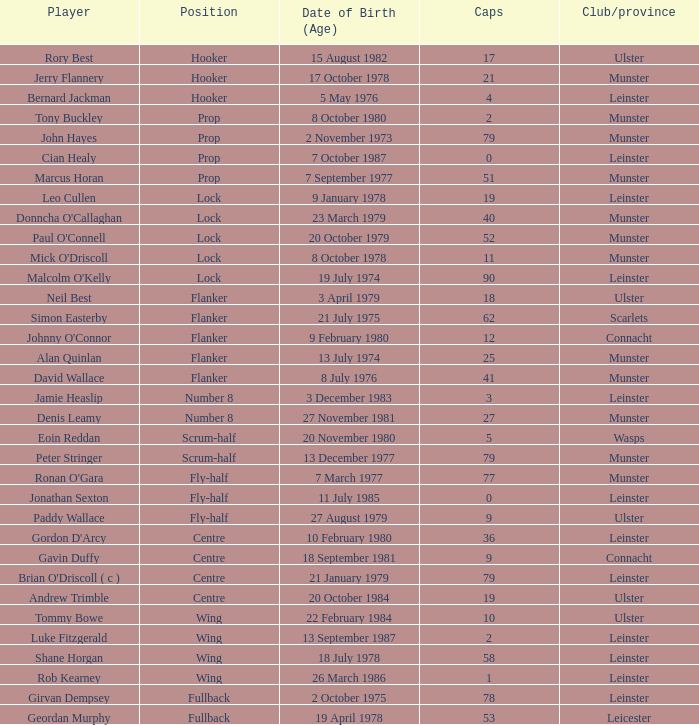Can you parse all the data within this table? {'header': ['Player', 'Position', 'Date of Birth (Age)', 'Caps', 'Club/province'], 'rows': [['Rory Best', 'Hooker', '15 August 1982', '17', 'Ulster'], ['Jerry Flannery', 'Hooker', '17 October 1978', '21', 'Munster'], ['Bernard Jackman', 'Hooker', '5 May 1976', '4', 'Leinster'], ['Tony Buckley', 'Prop', '8 October 1980', '2', 'Munster'], ['John Hayes', 'Prop', '2 November 1973', '79', 'Munster'], ['Cian Healy', 'Prop', '7 October 1987', '0', 'Leinster'], ['Marcus Horan', 'Prop', '7 September 1977', '51', 'Munster'], ['Leo Cullen', 'Lock', '9 January 1978', '19', 'Leinster'], ["Donncha O'Callaghan", 'Lock', '23 March 1979', '40', 'Munster'], ["Paul O'Connell", 'Lock', '20 October 1979', '52', 'Munster'], ["Mick O'Driscoll", 'Lock', '8 October 1978', '11', 'Munster'], ["Malcolm O'Kelly", 'Lock', '19 July 1974', '90', 'Leinster'], ['Neil Best', 'Flanker', '3 April 1979', '18', 'Ulster'], ['Simon Easterby', 'Flanker', '21 July 1975', '62', 'Scarlets'], ["Johnny O'Connor", 'Flanker', '9 February 1980', '12', 'Connacht'], ['Alan Quinlan', 'Flanker', '13 July 1974', '25', 'Munster'], ['David Wallace', 'Flanker', '8 July 1976', '41', 'Munster'], ['Jamie Heaslip', 'Number 8', '3 December 1983', '3', 'Leinster'], ['Denis Leamy', 'Number 8', '27 November 1981', '27', 'Munster'], ['Eoin Reddan', 'Scrum-half', '20 November 1980', '5', 'Wasps'], ['Peter Stringer', 'Scrum-half', '13 December 1977', '79', 'Munster'], ["Ronan O'Gara", 'Fly-half', '7 March 1977', '77', 'Munster'], ['Jonathan Sexton', 'Fly-half', '11 July 1985', '0', 'Leinster'], ['Paddy Wallace', 'Fly-half', '27 August 1979', '9', 'Ulster'], ["Gordon D'Arcy", 'Centre', '10 February 1980', '36', 'Leinster'], ['Gavin Duffy', 'Centre', '18 September 1981', '9', 'Connacht'], ["Brian O'Driscoll ( c )", 'Centre', '21 January 1979', '79', 'Leinster'], ['Andrew Trimble', 'Centre', '20 October 1984', '19', 'Ulster'], ['Tommy Bowe', 'Wing', '22 February 1984', '10', 'Ulster'], ['Luke Fitzgerald', 'Wing', '13 September 1987', '2', 'Leinster'], ['Shane Horgan', 'Wing', '18 July 1978', '58', 'Leinster'], ['Rob Kearney', 'Wing', '26 March 1986', '1', 'Leinster'], ['Girvan Dempsey', 'Fullback', '2 October 1975', '78', 'Leinster'], ['Geordan Murphy', 'Fullback', '19 April 1978', '53', 'Leicester']]} Paddy Wallace who plays the position of fly-half has how many Caps? 9.0. 